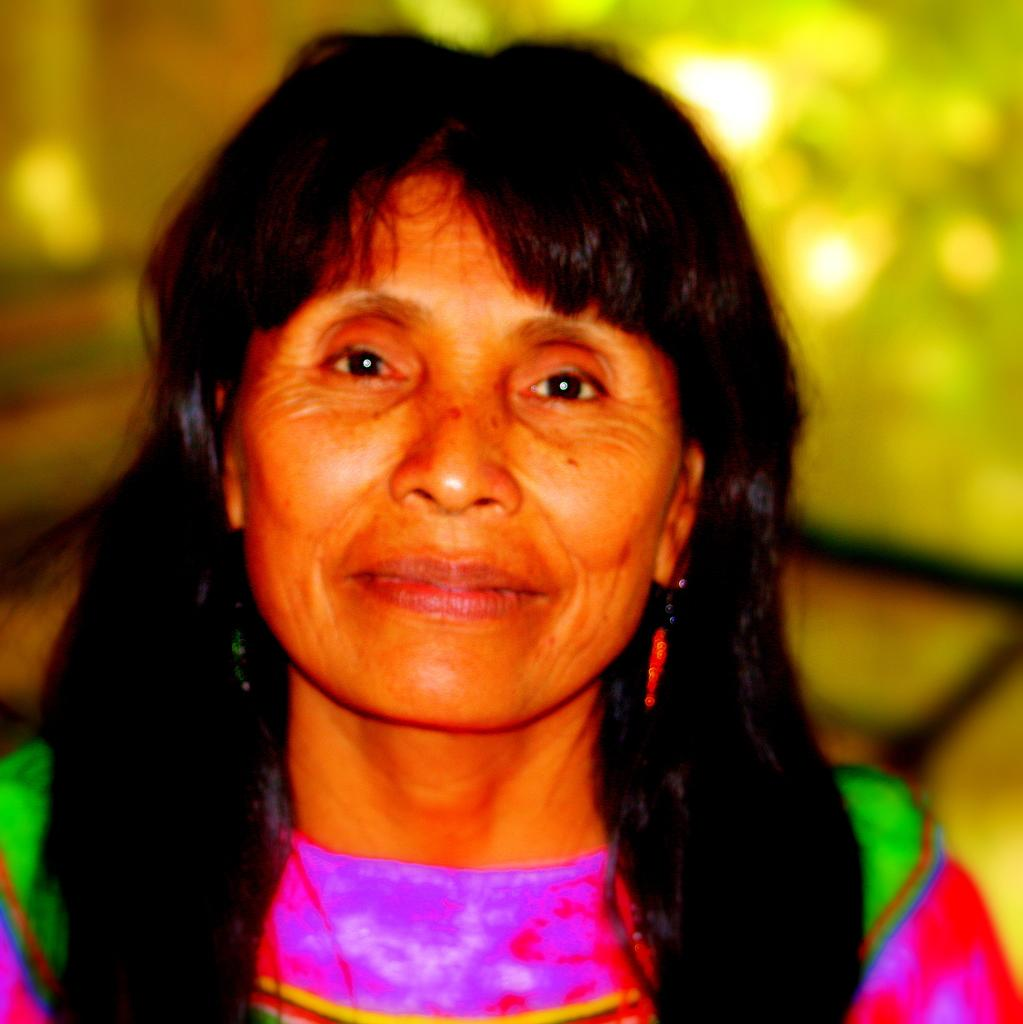Who is the main subject in the image? There is a woman in the image. What is the woman wearing in the image? The woman is wearing earrings in the image. What is the woman's facial expression in the image? The woman is smiling in the image. Can you describe the background of the image? The background of the image is blurred. What type of van can be seen in the background of the image? There is no van present in the image; the background is blurred. 